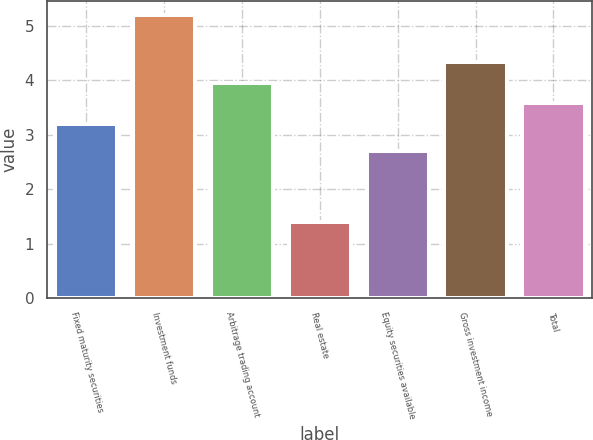<chart> <loc_0><loc_0><loc_500><loc_500><bar_chart><fcel>Fixed maturity securities<fcel>Investment funds<fcel>Arbitrage trading account<fcel>Real estate<fcel>Equity securities available<fcel>Gross investment income<fcel>Total<nl><fcel>3.2<fcel>5.2<fcel>3.96<fcel>1.4<fcel>2.7<fcel>4.34<fcel>3.58<nl></chart> 